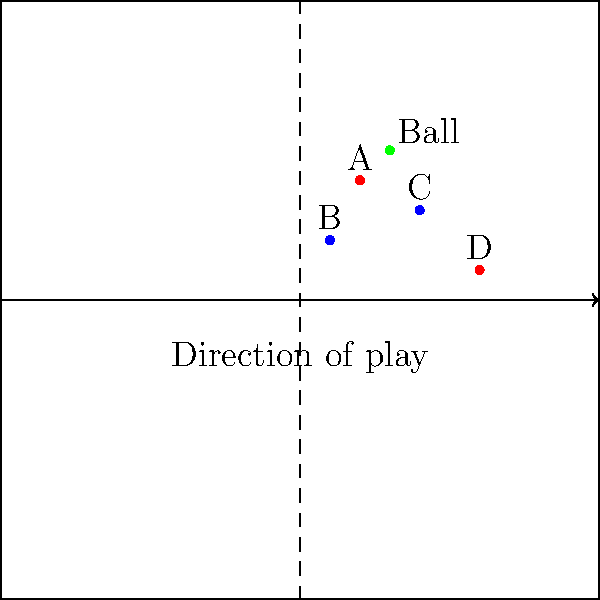In the diagram above, Team Red (players A and D) is attacking from left to right. The green dot represents the ball, which has just been played by player A. At the moment the ball is played, is player D in an offside position? To determine if player D is in an offside position, we need to follow these steps:

1. Identify the second-last defender: In this case, it's player C (the last defender would be the goalkeeper, not shown in the diagram).

2. Compare player D's position to the second-last defender: Player D is clearly closer to the goal line than player C.

3. Check if player D is in his own half: Player D is in the opponent's half (right side of the center line).

4. Verify if player D is involved in active play: As the question states the ball has just been played by player A, we assume player D is involved in active play.

5. Consider the position of the ball: Player D is ahead of the ball when it's played by player A.

Given these observations, player D meets all the criteria for being in an offside position:
- He is in the opponents' half of the field
- He is nearer to the opponents' goal line than both the ball and the second-last opponent
- He is involved in active play as the ball has just been played by a teammate

Therefore, player D is in an offside position when the ball is played by player A.
Answer: Yes, player D is in an offside position. 